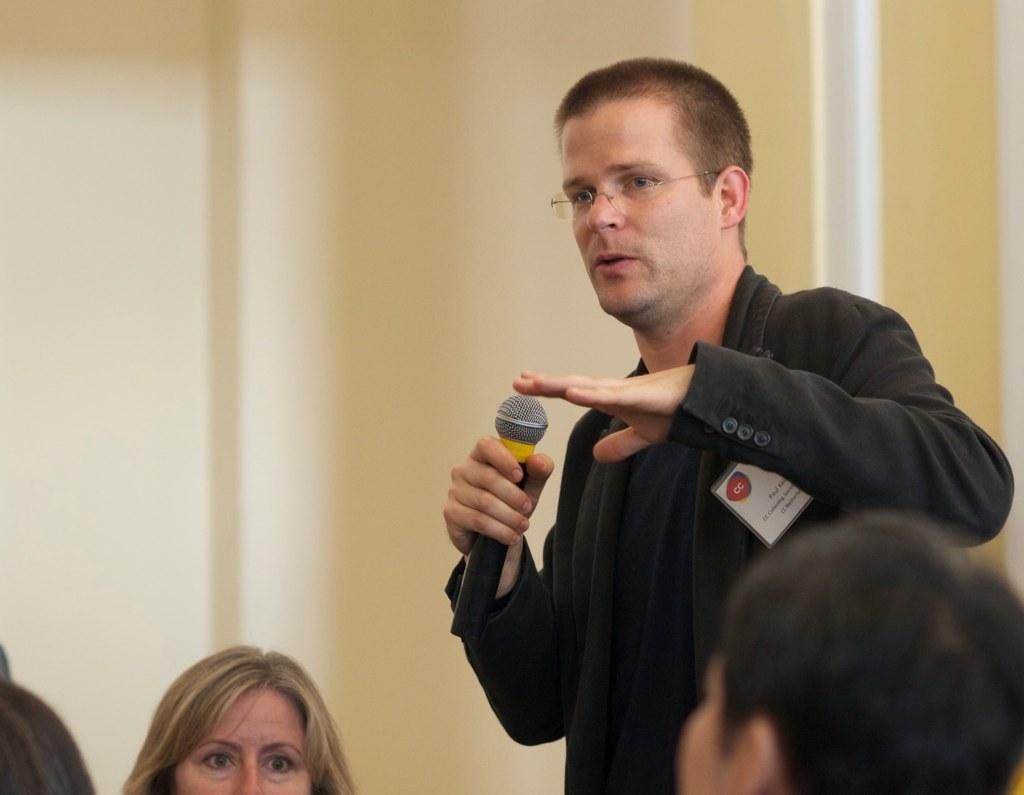How many people are in the image? There is a group of people in the image. What is the man in the image doing? The man is speaking in the image. How is the man amplifying his voice while speaking? The man is using a microphone while speaking. What direction is the stream flowing in the image? There is no stream present in the image. 